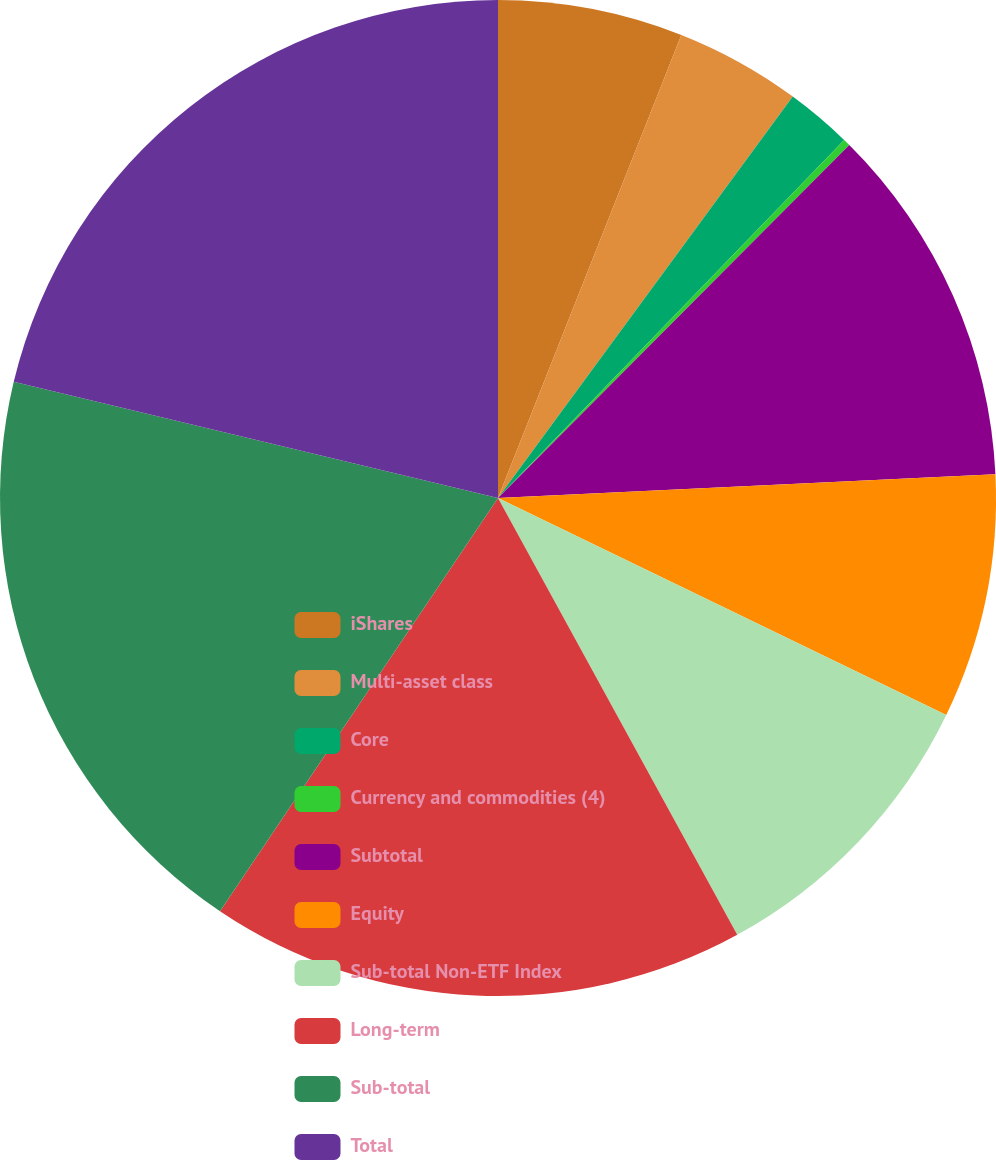<chart> <loc_0><loc_0><loc_500><loc_500><pie_chart><fcel>iShares<fcel>Multi-asset class<fcel>Core<fcel>Currency and commodities (4)<fcel>Subtotal<fcel>Equity<fcel>Sub-total Non-ETF Index<fcel>Long-term<fcel>Sub-total<fcel>Total<nl><fcel>6.0%<fcel>4.08%<fcel>2.15%<fcel>0.23%<fcel>11.78%<fcel>7.93%<fcel>9.85%<fcel>17.4%<fcel>19.32%<fcel>21.25%<nl></chart> 